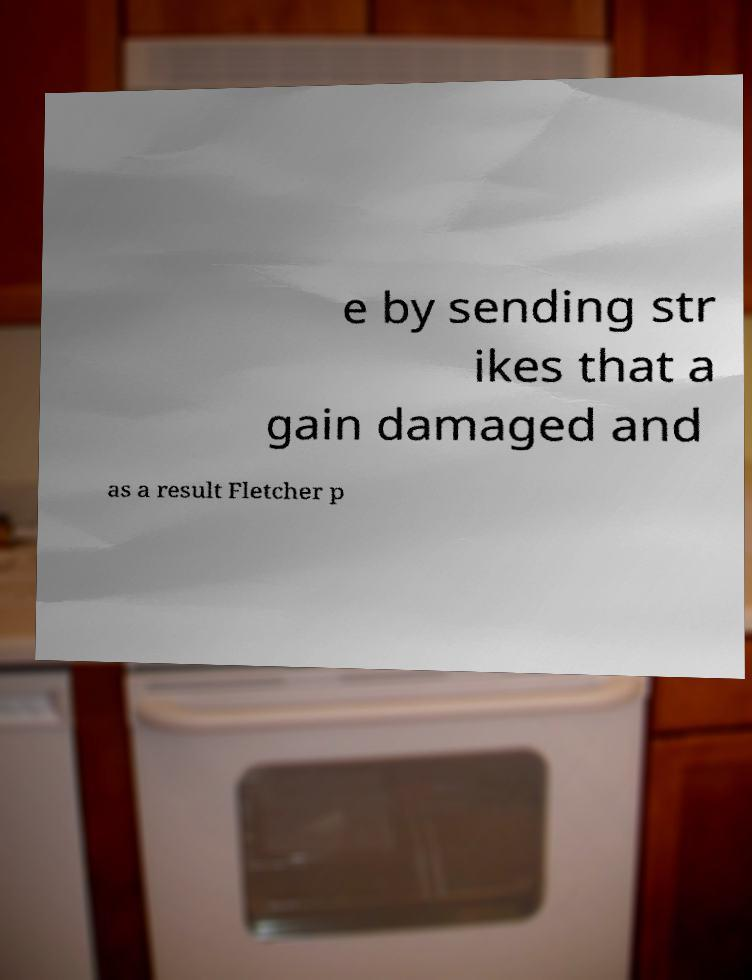Can you accurately transcribe the text from the provided image for me? e by sending str ikes that a gain damaged and as a result Fletcher p 